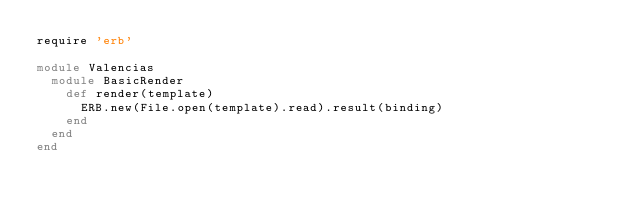Convert code to text. <code><loc_0><loc_0><loc_500><loc_500><_Ruby_>require 'erb'

module Valencias
  module BasicRender
    def render(template)
      ERB.new(File.open(template).read).result(binding)
    end
  end
end
</code> 